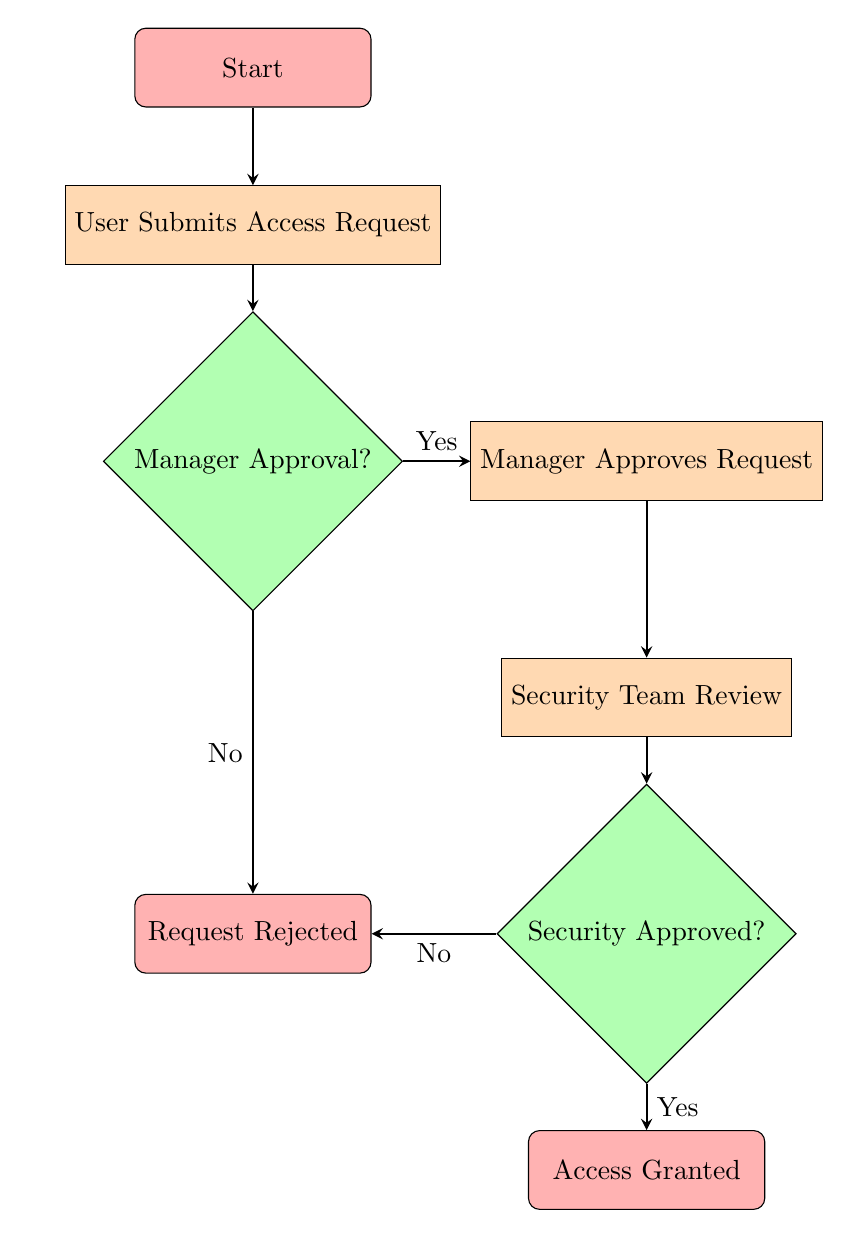What is the first step in the flowchart? The first node in the flowchart is labeled "Start," which indicates the beginning of the process.
Answer: Start How many decision nodes are present in the diagram? There are two decision nodes: "Manager Approval?" and "Security Approved?".
Answer: 2 What happens if the manager does not approve the request? If the manager does not approve the request, the flowchart indicates that the path leads to "Request Rejected."
Answer: Request Rejected What is the final node in the flowchart? The final node, where the process ends, is labeled "Access Granted."
Answer: Access Granted If the security team does not approve the request, where does the process lead? If the security team does not approve the request, the diagram shows that the outcome is "Request Rejected." This means the flow leads to that node.
Answer: Request Rejected What must happen after the manager approves the request? After approval from the manager, the next step that must occur is "Security Team Review."
Answer: Security Team Review What is the outcome if both the manager and the security team approve the request? If both approvals are obtained, the final outcome on the flowchart is "Access Granted." This follows the paths from both decision nodes leading to success.
Answer: Access Granted Which part of the flowchart indicates a rejection? The flowchart has two ends labeled "Request Rejected," where the process concludes if either the manager or the security team denies the request.
Answer: Request Rejected 